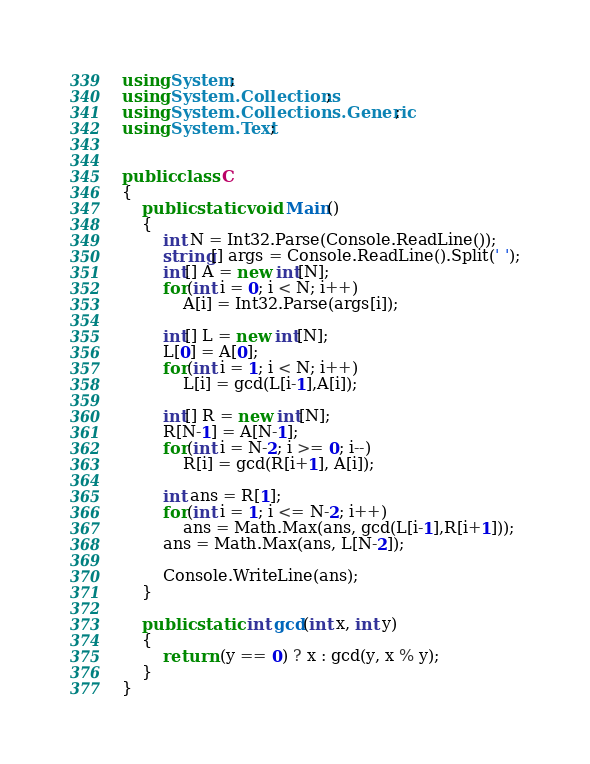<code> <loc_0><loc_0><loc_500><loc_500><_C#_>using System;
using System.Collections;
using System.Collections.Generic;
using System.Text;


public class C
{
	public static void Main()
	{	
		int N = Int32.Parse(Console.ReadLine());
		string[] args = Console.ReadLine().Split(' ');
		int[] A = new int[N];
		for(int i = 0; i < N; i++)
			A[i] = Int32.Parse(args[i]);

		int[] L = new int[N];
		L[0] = A[0];
		for(int i = 1; i < N; i++)
			L[i] = gcd(L[i-1],A[i]);

		int[] R = new int[N];
		R[N-1] = A[N-1];
		for(int i = N-2; i >= 0; i--)
			R[i] = gcd(R[i+1], A[i]);

		int ans = R[1];
		for(int i = 1; i <= N-2; i++)
			ans = Math.Max(ans, gcd(L[i-1],R[i+1]));
		ans = Math.Max(ans, L[N-2]);

		Console.WriteLine(ans);
	}	

	public static int gcd(int x, int y)
	{
		return (y == 0) ? x : gcd(y, x % y);
	}
}



</code> 